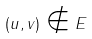<formula> <loc_0><loc_0><loc_500><loc_500>( u , v ) \notin E</formula> 